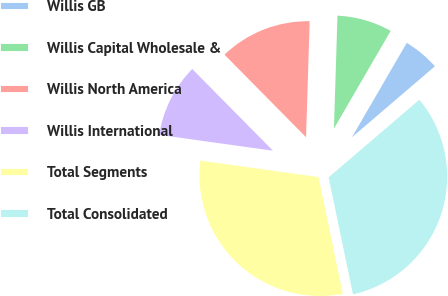Convert chart. <chart><loc_0><loc_0><loc_500><loc_500><pie_chart><fcel>Willis GB<fcel>Willis Capital Wholesale &<fcel>Willis North America<fcel>Willis International<fcel>Total Segments<fcel>Total Consolidated<nl><fcel>5.36%<fcel>7.88%<fcel>12.9%<fcel>10.39%<fcel>30.48%<fcel>32.99%<nl></chart> 